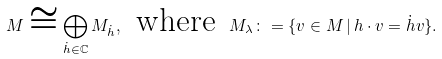<formula> <loc_0><loc_0><loc_500><loc_500>M \cong \bigoplus _ { { \dot { h } } \in \mathbb { C } } M _ { \dot { h } } , \, \text { where } \, M _ { \lambda } \colon = \{ v \in M \, | \, h \cdot v = { \dot { h } } v \} .</formula> 